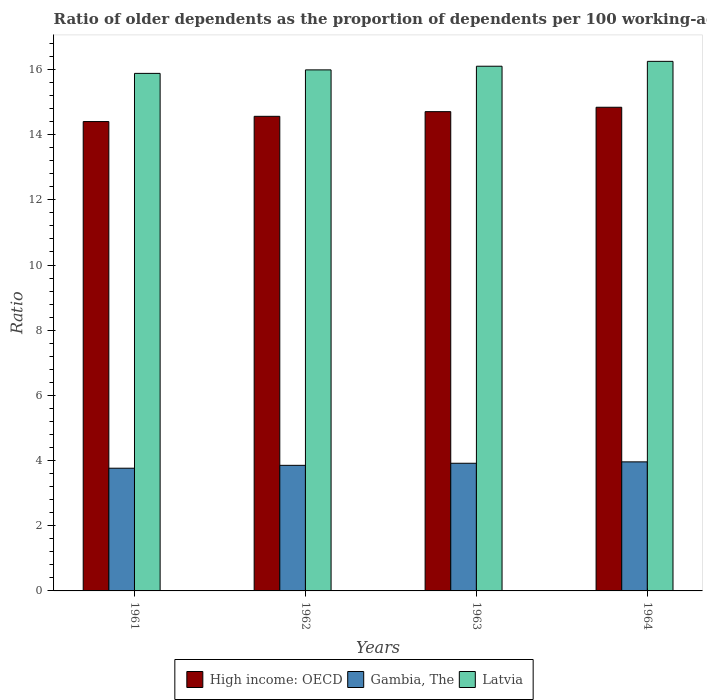How many bars are there on the 2nd tick from the left?
Offer a terse response. 3. What is the label of the 3rd group of bars from the left?
Provide a short and direct response. 1963. In how many cases, is the number of bars for a given year not equal to the number of legend labels?
Provide a short and direct response. 0. What is the age dependency ratio(old) in Latvia in 1963?
Give a very brief answer. 16.1. Across all years, what is the maximum age dependency ratio(old) in Latvia?
Give a very brief answer. 16.25. Across all years, what is the minimum age dependency ratio(old) in Gambia, The?
Offer a terse response. 3.77. In which year was the age dependency ratio(old) in High income: OECD maximum?
Provide a short and direct response. 1964. In which year was the age dependency ratio(old) in Gambia, The minimum?
Offer a terse response. 1961. What is the total age dependency ratio(old) in Latvia in the graph?
Offer a terse response. 64.22. What is the difference between the age dependency ratio(old) in High income: OECD in 1963 and that in 1964?
Provide a succinct answer. -0.13. What is the difference between the age dependency ratio(old) in Latvia in 1963 and the age dependency ratio(old) in High income: OECD in 1964?
Your answer should be compact. 1.26. What is the average age dependency ratio(old) in Gambia, The per year?
Your answer should be very brief. 3.87. In the year 1963, what is the difference between the age dependency ratio(old) in Latvia and age dependency ratio(old) in Gambia, The?
Make the answer very short. 12.18. In how many years, is the age dependency ratio(old) in Gambia, The greater than 4.4?
Offer a very short reply. 0. What is the ratio of the age dependency ratio(old) in Latvia in 1961 to that in 1964?
Give a very brief answer. 0.98. Is the age dependency ratio(old) in High income: OECD in 1963 less than that in 1964?
Your answer should be compact. Yes. Is the difference between the age dependency ratio(old) in Latvia in 1961 and 1962 greater than the difference between the age dependency ratio(old) in Gambia, The in 1961 and 1962?
Your answer should be compact. No. What is the difference between the highest and the second highest age dependency ratio(old) in High income: OECD?
Provide a succinct answer. 0.13. What is the difference between the highest and the lowest age dependency ratio(old) in High income: OECD?
Your answer should be very brief. 0.44. Is the sum of the age dependency ratio(old) in Latvia in 1961 and 1963 greater than the maximum age dependency ratio(old) in High income: OECD across all years?
Give a very brief answer. Yes. What does the 3rd bar from the left in 1962 represents?
Offer a terse response. Latvia. What does the 2nd bar from the right in 1961 represents?
Provide a succinct answer. Gambia, The. How many bars are there?
Your answer should be compact. 12. What is the difference between two consecutive major ticks on the Y-axis?
Offer a terse response. 2. Are the values on the major ticks of Y-axis written in scientific E-notation?
Your response must be concise. No. Does the graph contain any zero values?
Give a very brief answer. No. Where does the legend appear in the graph?
Offer a terse response. Bottom center. How many legend labels are there?
Provide a succinct answer. 3. What is the title of the graph?
Keep it short and to the point. Ratio of older dependents as the proportion of dependents per 100 working-age population. Does "Singapore" appear as one of the legend labels in the graph?
Your answer should be compact. No. What is the label or title of the Y-axis?
Make the answer very short. Ratio. What is the Ratio of High income: OECD in 1961?
Your response must be concise. 14.4. What is the Ratio of Gambia, The in 1961?
Provide a succinct answer. 3.77. What is the Ratio in Latvia in 1961?
Your answer should be compact. 15.88. What is the Ratio in High income: OECD in 1962?
Provide a short and direct response. 14.56. What is the Ratio in Gambia, The in 1962?
Give a very brief answer. 3.85. What is the Ratio of Latvia in 1962?
Your answer should be very brief. 15.99. What is the Ratio in High income: OECD in 1963?
Your answer should be very brief. 14.71. What is the Ratio in Gambia, The in 1963?
Provide a short and direct response. 3.92. What is the Ratio in Latvia in 1963?
Your answer should be very brief. 16.1. What is the Ratio of High income: OECD in 1964?
Provide a short and direct response. 14.84. What is the Ratio in Gambia, The in 1964?
Ensure brevity in your answer.  3.96. What is the Ratio of Latvia in 1964?
Your answer should be very brief. 16.25. Across all years, what is the maximum Ratio of High income: OECD?
Provide a short and direct response. 14.84. Across all years, what is the maximum Ratio in Gambia, The?
Your answer should be very brief. 3.96. Across all years, what is the maximum Ratio in Latvia?
Provide a succinct answer. 16.25. Across all years, what is the minimum Ratio of High income: OECD?
Offer a terse response. 14.4. Across all years, what is the minimum Ratio in Gambia, The?
Your answer should be very brief. 3.77. Across all years, what is the minimum Ratio in Latvia?
Your answer should be compact. 15.88. What is the total Ratio in High income: OECD in the graph?
Your answer should be compact. 58.51. What is the total Ratio of Gambia, The in the graph?
Your response must be concise. 15.5. What is the total Ratio of Latvia in the graph?
Give a very brief answer. 64.22. What is the difference between the Ratio in High income: OECD in 1961 and that in 1962?
Provide a short and direct response. -0.16. What is the difference between the Ratio of Gambia, The in 1961 and that in 1962?
Keep it short and to the point. -0.09. What is the difference between the Ratio of Latvia in 1961 and that in 1962?
Your answer should be very brief. -0.11. What is the difference between the Ratio in High income: OECD in 1961 and that in 1963?
Make the answer very short. -0.3. What is the difference between the Ratio of Gambia, The in 1961 and that in 1963?
Offer a very short reply. -0.15. What is the difference between the Ratio of Latvia in 1961 and that in 1963?
Keep it short and to the point. -0.22. What is the difference between the Ratio of High income: OECD in 1961 and that in 1964?
Your response must be concise. -0.44. What is the difference between the Ratio of Gambia, The in 1961 and that in 1964?
Keep it short and to the point. -0.19. What is the difference between the Ratio in Latvia in 1961 and that in 1964?
Provide a short and direct response. -0.37. What is the difference between the Ratio of High income: OECD in 1962 and that in 1963?
Offer a terse response. -0.14. What is the difference between the Ratio in Gambia, The in 1962 and that in 1963?
Provide a succinct answer. -0.06. What is the difference between the Ratio in Latvia in 1962 and that in 1963?
Offer a terse response. -0.11. What is the difference between the Ratio of High income: OECD in 1962 and that in 1964?
Offer a very short reply. -0.28. What is the difference between the Ratio of Gambia, The in 1962 and that in 1964?
Provide a succinct answer. -0.11. What is the difference between the Ratio in Latvia in 1962 and that in 1964?
Make the answer very short. -0.26. What is the difference between the Ratio in High income: OECD in 1963 and that in 1964?
Offer a terse response. -0.13. What is the difference between the Ratio of Gambia, The in 1963 and that in 1964?
Ensure brevity in your answer.  -0.04. What is the difference between the Ratio in Latvia in 1963 and that in 1964?
Offer a terse response. -0.15. What is the difference between the Ratio of High income: OECD in 1961 and the Ratio of Gambia, The in 1962?
Provide a succinct answer. 10.55. What is the difference between the Ratio in High income: OECD in 1961 and the Ratio in Latvia in 1962?
Provide a short and direct response. -1.59. What is the difference between the Ratio of Gambia, The in 1961 and the Ratio of Latvia in 1962?
Your answer should be compact. -12.22. What is the difference between the Ratio in High income: OECD in 1961 and the Ratio in Gambia, The in 1963?
Your response must be concise. 10.48. What is the difference between the Ratio in High income: OECD in 1961 and the Ratio in Latvia in 1963?
Give a very brief answer. -1.7. What is the difference between the Ratio of Gambia, The in 1961 and the Ratio of Latvia in 1963?
Give a very brief answer. -12.33. What is the difference between the Ratio of High income: OECD in 1961 and the Ratio of Gambia, The in 1964?
Offer a terse response. 10.44. What is the difference between the Ratio of High income: OECD in 1961 and the Ratio of Latvia in 1964?
Offer a very short reply. -1.85. What is the difference between the Ratio of Gambia, The in 1961 and the Ratio of Latvia in 1964?
Give a very brief answer. -12.48. What is the difference between the Ratio of High income: OECD in 1962 and the Ratio of Gambia, The in 1963?
Your response must be concise. 10.65. What is the difference between the Ratio of High income: OECD in 1962 and the Ratio of Latvia in 1963?
Ensure brevity in your answer.  -1.54. What is the difference between the Ratio in Gambia, The in 1962 and the Ratio in Latvia in 1963?
Offer a very short reply. -12.25. What is the difference between the Ratio of High income: OECD in 1962 and the Ratio of Gambia, The in 1964?
Your answer should be compact. 10.6. What is the difference between the Ratio in High income: OECD in 1962 and the Ratio in Latvia in 1964?
Keep it short and to the point. -1.69. What is the difference between the Ratio in Gambia, The in 1962 and the Ratio in Latvia in 1964?
Keep it short and to the point. -12.4. What is the difference between the Ratio of High income: OECD in 1963 and the Ratio of Gambia, The in 1964?
Provide a short and direct response. 10.75. What is the difference between the Ratio of High income: OECD in 1963 and the Ratio of Latvia in 1964?
Keep it short and to the point. -1.54. What is the difference between the Ratio in Gambia, The in 1963 and the Ratio in Latvia in 1964?
Offer a terse response. -12.33. What is the average Ratio of High income: OECD per year?
Your answer should be very brief. 14.63. What is the average Ratio of Gambia, The per year?
Give a very brief answer. 3.87. What is the average Ratio of Latvia per year?
Your response must be concise. 16.05. In the year 1961, what is the difference between the Ratio in High income: OECD and Ratio in Gambia, The?
Provide a short and direct response. 10.64. In the year 1961, what is the difference between the Ratio in High income: OECD and Ratio in Latvia?
Make the answer very short. -1.48. In the year 1961, what is the difference between the Ratio of Gambia, The and Ratio of Latvia?
Ensure brevity in your answer.  -12.11. In the year 1962, what is the difference between the Ratio of High income: OECD and Ratio of Gambia, The?
Offer a terse response. 10.71. In the year 1962, what is the difference between the Ratio in High income: OECD and Ratio in Latvia?
Your answer should be very brief. -1.42. In the year 1962, what is the difference between the Ratio of Gambia, The and Ratio of Latvia?
Your answer should be very brief. -12.13. In the year 1963, what is the difference between the Ratio in High income: OECD and Ratio in Gambia, The?
Offer a very short reply. 10.79. In the year 1963, what is the difference between the Ratio of High income: OECD and Ratio of Latvia?
Give a very brief answer. -1.39. In the year 1963, what is the difference between the Ratio in Gambia, The and Ratio in Latvia?
Make the answer very short. -12.18. In the year 1964, what is the difference between the Ratio of High income: OECD and Ratio of Gambia, The?
Your response must be concise. 10.88. In the year 1964, what is the difference between the Ratio in High income: OECD and Ratio in Latvia?
Ensure brevity in your answer.  -1.41. In the year 1964, what is the difference between the Ratio in Gambia, The and Ratio in Latvia?
Ensure brevity in your answer.  -12.29. What is the ratio of the Ratio in High income: OECD in 1961 to that in 1962?
Offer a terse response. 0.99. What is the ratio of the Ratio of Gambia, The in 1961 to that in 1962?
Provide a succinct answer. 0.98. What is the ratio of the Ratio in High income: OECD in 1961 to that in 1963?
Your answer should be very brief. 0.98. What is the ratio of the Ratio of Gambia, The in 1961 to that in 1963?
Give a very brief answer. 0.96. What is the ratio of the Ratio of Latvia in 1961 to that in 1963?
Your answer should be very brief. 0.99. What is the ratio of the Ratio in High income: OECD in 1961 to that in 1964?
Keep it short and to the point. 0.97. What is the ratio of the Ratio in Gambia, The in 1961 to that in 1964?
Your answer should be compact. 0.95. What is the ratio of the Ratio of Latvia in 1961 to that in 1964?
Provide a succinct answer. 0.98. What is the ratio of the Ratio of High income: OECD in 1962 to that in 1963?
Offer a very short reply. 0.99. What is the ratio of the Ratio in Gambia, The in 1962 to that in 1963?
Ensure brevity in your answer.  0.98. What is the ratio of the Ratio of Latvia in 1962 to that in 1963?
Give a very brief answer. 0.99. What is the ratio of the Ratio in High income: OECD in 1962 to that in 1964?
Your answer should be very brief. 0.98. What is the ratio of the Ratio of Gambia, The in 1962 to that in 1964?
Provide a short and direct response. 0.97. What is the ratio of the Ratio of Latvia in 1962 to that in 1964?
Your answer should be very brief. 0.98. What is the ratio of the Ratio of High income: OECD in 1963 to that in 1964?
Give a very brief answer. 0.99. What is the ratio of the Ratio of Gambia, The in 1963 to that in 1964?
Keep it short and to the point. 0.99. What is the ratio of the Ratio in Latvia in 1963 to that in 1964?
Ensure brevity in your answer.  0.99. What is the difference between the highest and the second highest Ratio in High income: OECD?
Your response must be concise. 0.13. What is the difference between the highest and the second highest Ratio in Gambia, The?
Provide a short and direct response. 0.04. What is the difference between the highest and the second highest Ratio of Latvia?
Your answer should be compact. 0.15. What is the difference between the highest and the lowest Ratio in High income: OECD?
Provide a succinct answer. 0.44. What is the difference between the highest and the lowest Ratio in Gambia, The?
Offer a very short reply. 0.19. What is the difference between the highest and the lowest Ratio in Latvia?
Make the answer very short. 0.37. 